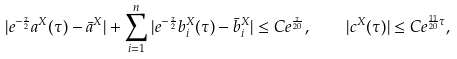Convert formula to latex. <formula><loc_0><loc_0><loc_500><loc_500>| e ^ { - \frac { \tau } { 2 } } a ^ { X } ( \tau ) - \bar { a } ^ { X } | + \sum _ { i = 1 } ^ { n } | e ^ { - \frac { \tau } { 2 } } b _ { i } ^ { X } ( \tau ) - \bar { b } _ { i } ^ { X } | \leq C e ^ { \frac { \tau } { 2 0 } } , \quad | c ^ { X } ( \tau ) | \leq C e ^ { \frac { 1 1 } { 2 0 } \tau } ,</formula> 